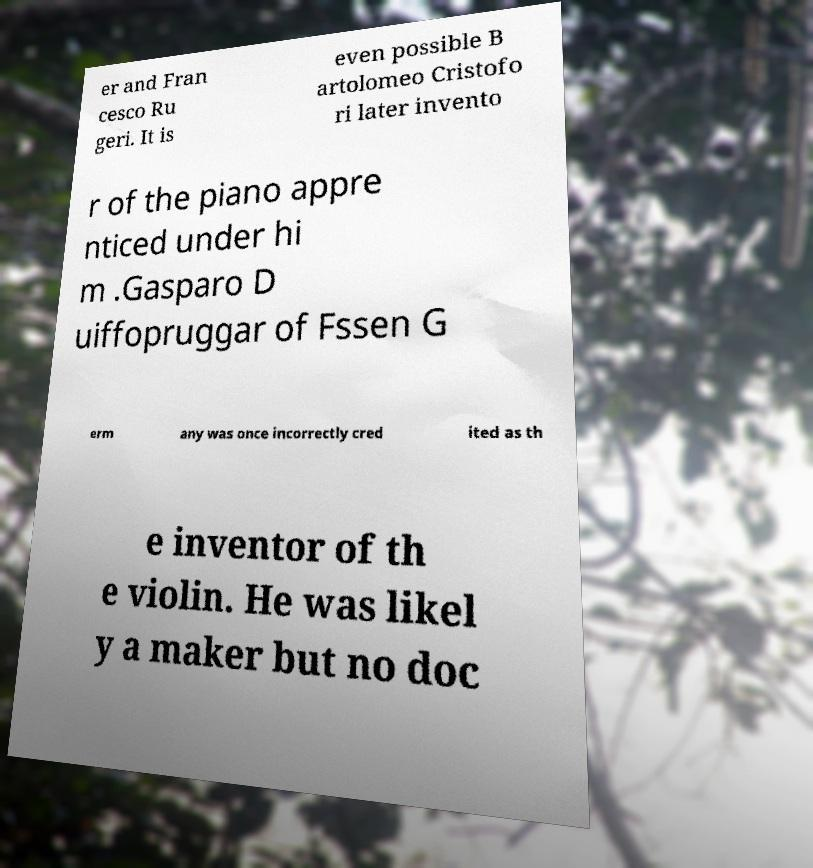Can you read and provide the text displayed in the image?This photo seems to have some interesting text. Can you extract and type it out for me? er and Fran cesco Ru geri. It is even possible B artolomeo Cristofo ri later invento r of the piano appre nticed under hi m .Gasparo D uiffopruggar of Fssen G erm any was once incorrectly cred ited as th e inventor of th e violin. He was likel y a maker but no doc 